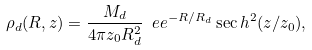<formula> <loc_0><loc_0><loc_500><loc_500>\rho _ { d } ( R , z ) = \frac { M _ { d } } { 4 \pi z _ { 0 } R _ { d } ^ { 2 } } \ e e ^ { - R / R _ { d } } \sec h ^ { 2 } ( z / z _ { 0 } ) ,</formula> 